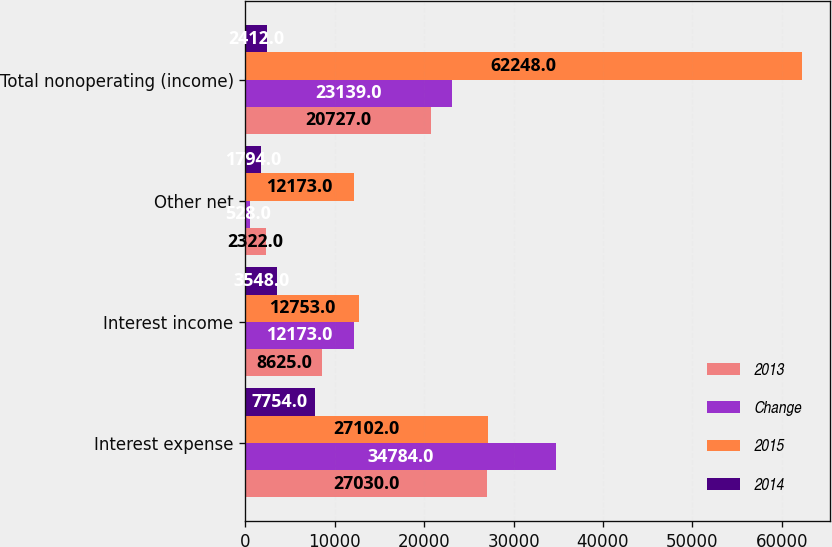<chart> <loc_0><loc_0><loc_500><loc_500><stacked_bar_chart><ecel><fcel>Interest expense<fcel>Interest income<fcel>Other net<fcel>Total nonoperating (income)<nl><fcel>2013<fcel>27030<fcel>8625<fcel>2322<fcel>20727<nl><fcel>Change<fcel>34784<fcel>12173<fcel>528<fcel>23139<nl><fcel>2015<fcel>27102<fcel>12753<fcel>12173<fcel>62248<nl><fcel>2014<fcel>7754<fcel>3548<fcel>1794<fcel>2412<nl></chart> 